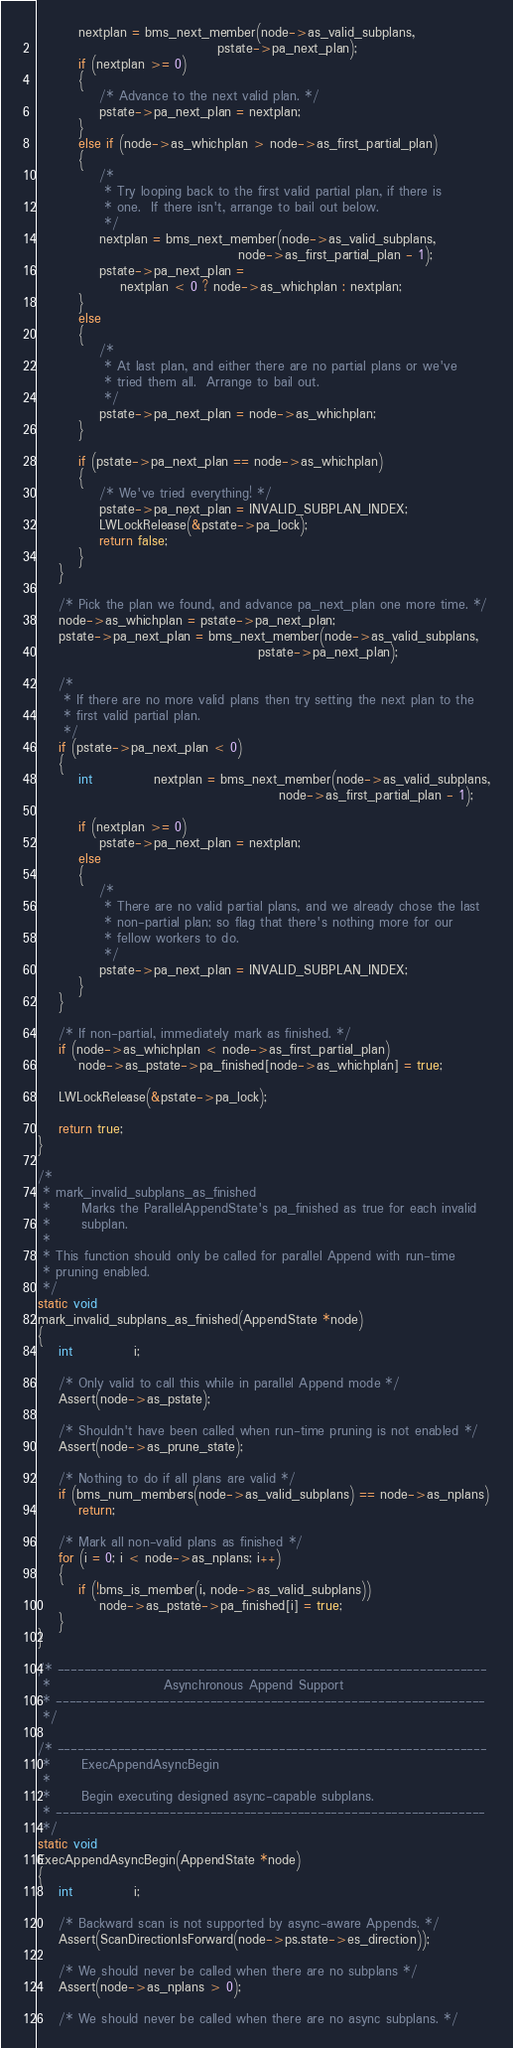Convert code to text. <code><loc_0><loc_0><loc_500><loc_500><_C_>
		nextplan = bms_next_member(node->as_valid_subplans,
								   pstate->pa_next_plan);
		if (nextplan >= 0)
		{
			/* Advance to the next valid plan. */
			pstate->pa_next_plan = nextplan;
		}
		else if (node->as_whichplan > node->as_first_partial_plan)
		{
			/*
			 * Try looping back to the first valid partial plan, if there is
			 * one.  If there isn't, arrange to bail out below.
			 */
			nextplan = bms_next_member(node->as_valid_subplans,
									   node->as_first_partial_plan - 1);
			pstate->pa_next_plan =
				nextplan < 0 ? node->as_whichplan : nextplan;
		}
		else
		{
			/*
			 * At last plan, and either there are no partial plans or we've
			 * tried them all.  Arrange to bail out.
			 */
			pstate->pa_next_plan = node->as_whichplan;
		}

		if (pstate->pa_next_plan == node->as_whichplan)
		{
			/* We've tried everything! */
			pstate->pa_next_plan = INVALID_SUBPLAN_INDEX;
			LWLockRelease(&pstate->pa_lock);
			return false;
		}
	}

	/* Pick the plan we found, and advance pa_next_plan one more time. */
	node->as_whichplan = pstate->pa_next_plan;
	pstate->pa_next_plan = bms_next_member(node->as_valid_subplans,
										   pstate->pa_next_plan);

	/*
	 * If there are no more valid plans then try setting the next plan to the
	 * first valid partial plan.
	 */
	if (pstate->pa_next_plan < 0)
	{
		int			nextplan = bms_next_member(node->as_valid_subplans,
											   node->as_first_partial_plan - 1);

		if (nextplan >= 0)
			pstate->pa_next_plan = nextplan;
		else
		{
			/*
			 * There are no valid partial plans, and we already chose the last
			 * non-partial plan; so flag that there's nothing more for our
			 * fellow workers to do.
			 */
			pstate->pa_next_plan = INVALID_SUBPLAN_INDEX;
		}
	}

	/* If non-partial, immediately mark as finished. */
	if (node->as_whichplan < node->as_first_partial_plan)
		node->as_pstate->pa_finished[node->as_whichplan] = true;

	LWLockRelease(&pstate->pa_lock);

	return true;
}

/*
 * mark_invalid_subplans_as_finished
 *		Marks the ParallelAppendState's pa_finished as true for each invalid
 *		subplan.
 *
 * This function should only be called for parallel Append with run-time
 * pruning enabled.
 */
static void
mark_invalid_subplans_as_finished(AppendState *node)
{
	int			i;

	/* Only valid to call this while in parallel Append mode */
	Assert(node->as_pstate);

	/* Shouldn't have been called when run-time pruning is not enabled */
	Assert(node->as_prune_state);

	/* Nothing to do if all plans are valid */
	if (bms_num_members(node->as_valid_subplans) == node->as_nplans)
		return;

	/* Mark all non-valid plans as finished */
	for (i = 0; i < node->as_nplans; i++)
	{
		if (!bms_is_member(i, node->as_valid_subplans))
			node->as_pstate->pa_finished[i] = true;
	}
}

/* ----------------------------------------------------------------
 *						Asynchronous Append Support
 * ----------------------------------------------------------------
 */

/* ----------------------------------------------------------------
 *		ExecAppendAsyncBegin
 *
 *		Begin executing designed async-capable subplans.
 * ----------------------------------------------------------------
 */
static void
ExecAppendAsyncBegin(AppendState *node)
{
	int			i;

	/* Backward scan is not supported by async-aware Appends. */
	Assert(ScanDirectionIsForward(node->ps.state->es_direction));

	/* We should never be called when there are no subplans */
	Assert(node->as_nplans > 0);

	/* We should never be called when there are no async subplans. */</code> 